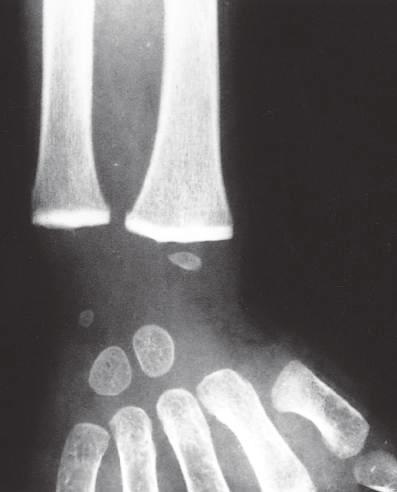paired remodeling of calcified cartilage in the epiphyses of the wrist has caused a marked increase in whose radiodensity , so that they are as radiopaque as the cortical bone?
Answer the question using a single word or phrase. Their 